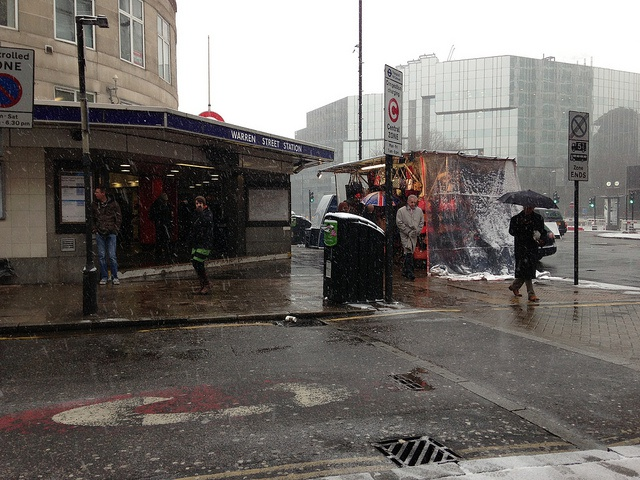Describe the objects in this image and their specific colors. I can see people in black, gray, and maroon tones, people in black, maroon, and gray tones, people in black, gray, and maroon tones, people in black, darkgreen, and maroon tones, and people in black, gray, and darkgreen tones in this image. 